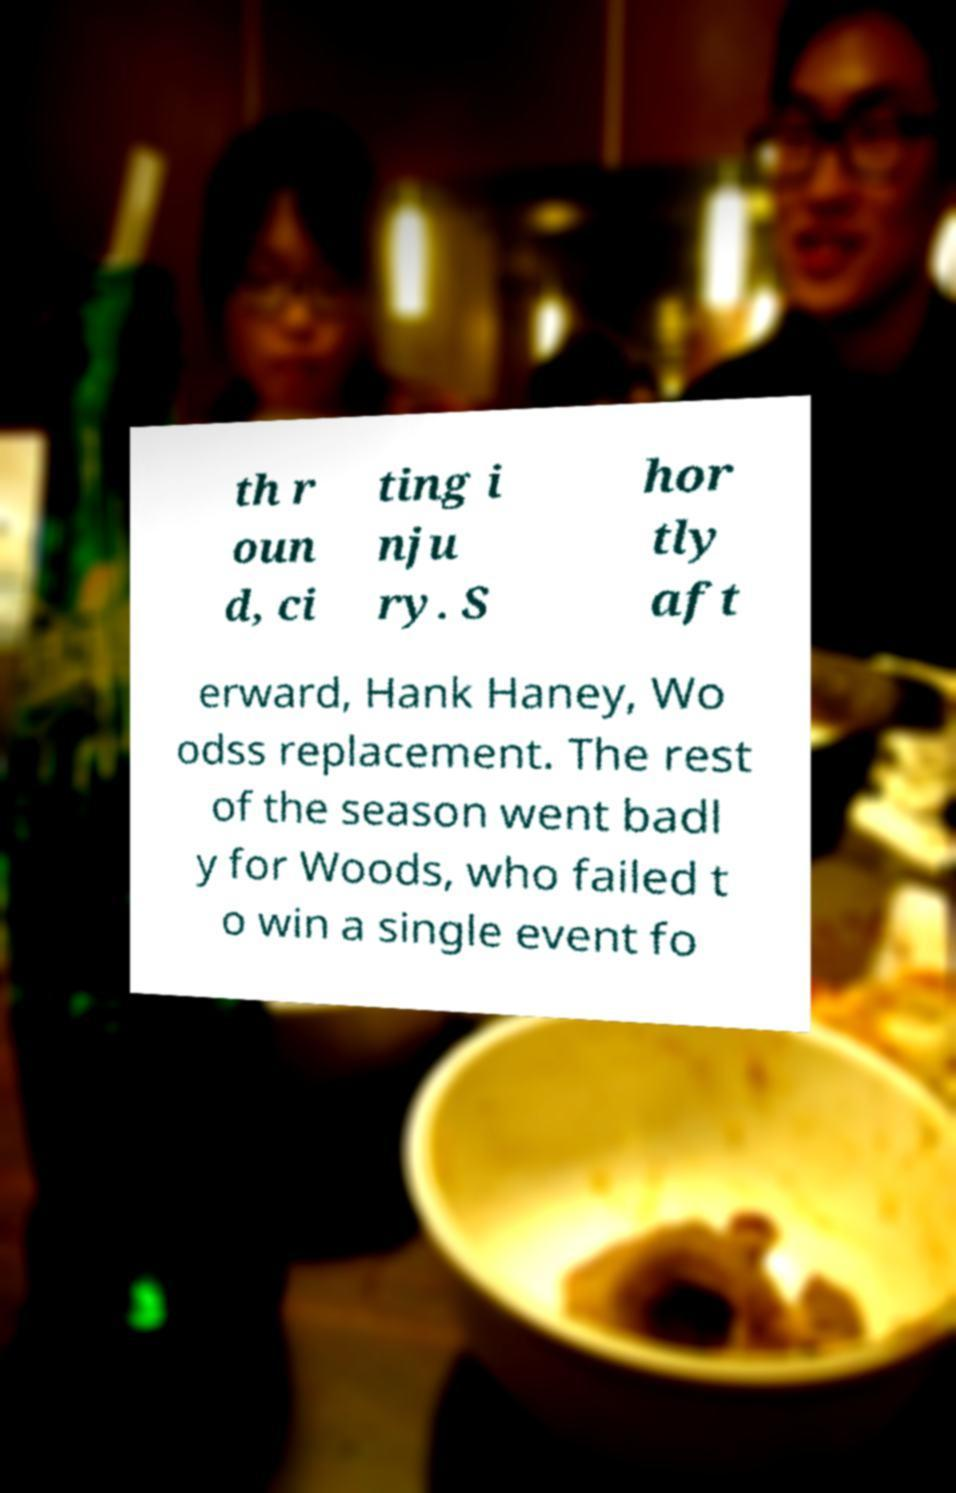For documentation purposes, I need the text within this image transcribed. Could you provide that? th r oun d, ci ting i nju ry. S hor tly aft erward, Hank Haney, Wo odss replacement. The rest of the season went badl y for Woods, who failed t o win a single event fo 